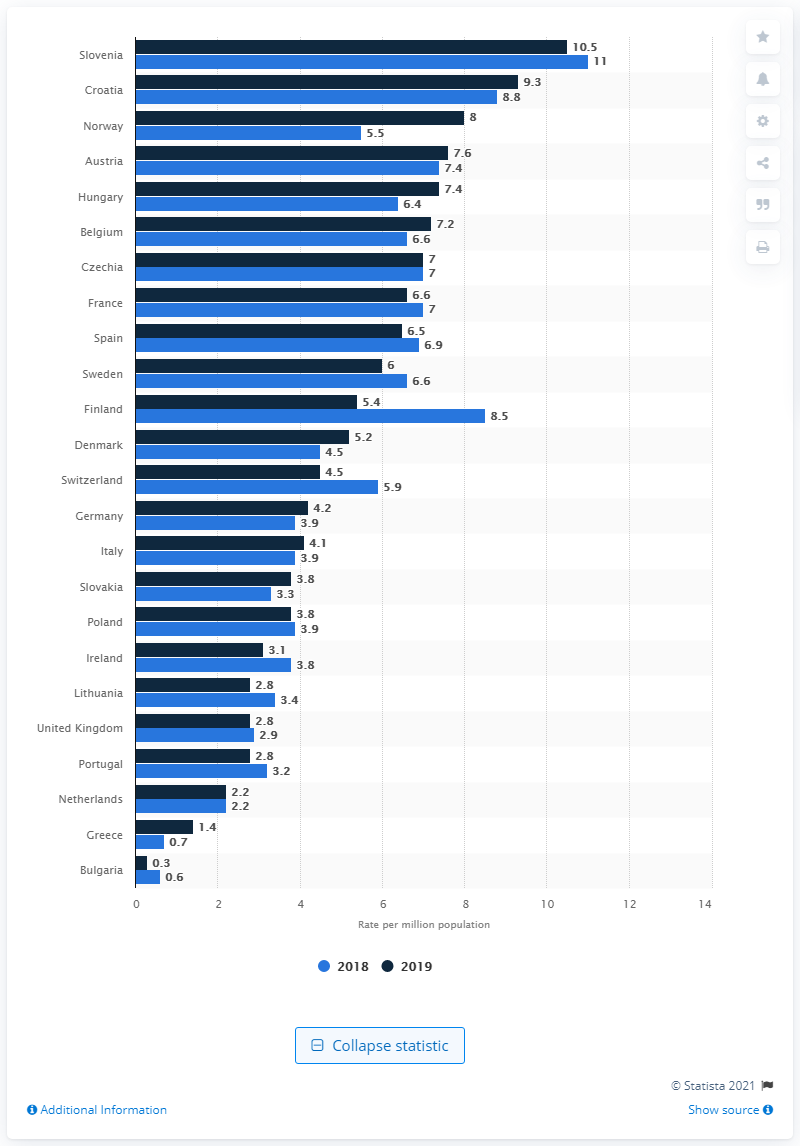Identify some key points in this picture. In 2019, Croatia had the highest rate of heart transplants among all countries. Slovenia had the highest rate of heart transplants in Europe in 2019. 